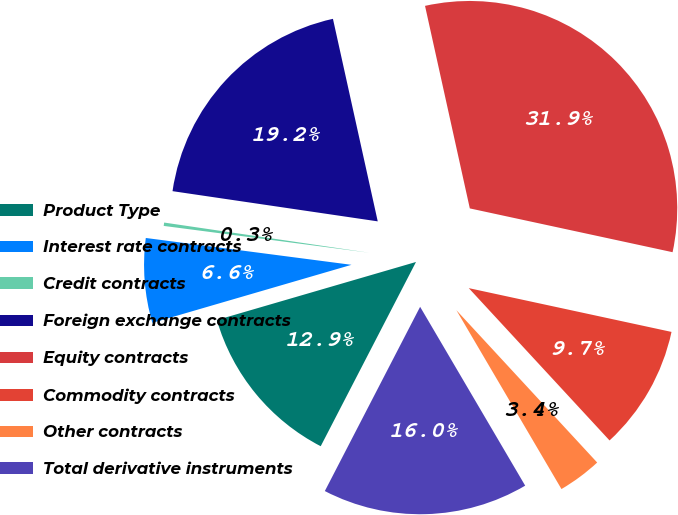<chart> <loc_0><loc_0><loc_500><loc_500><pie_chart><fcel>Product Type<fcel>Interest rate contracts<fcel>Credit contracts<fcel>Foreign exchange contracts<fcel>Equity contracts<fcel>Commodity contracts<fcel>Other contracts<fcel>Total derivative instruments<nl><fcel>12.89%<fcel>6.58%<fcel>0.26%<fcel>19.21%<fcel>31.85%<fcel>9.74%<fcel>3.42%<fcel>16.05%<nl></chart> 